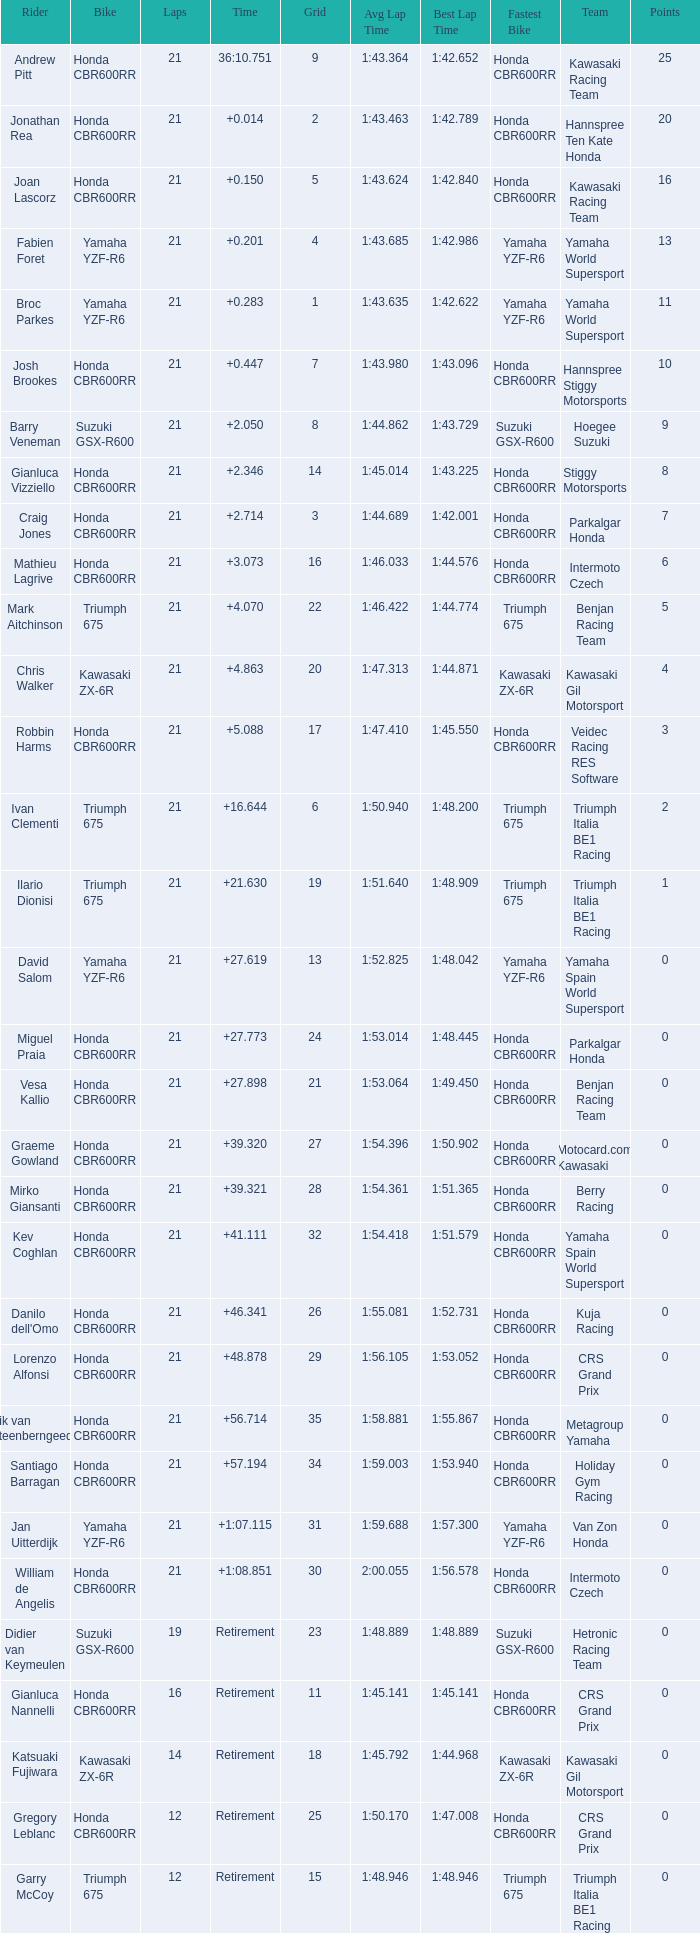What is the total of laps run by the driver with a grid under 17 and a time of +5.088? None. 